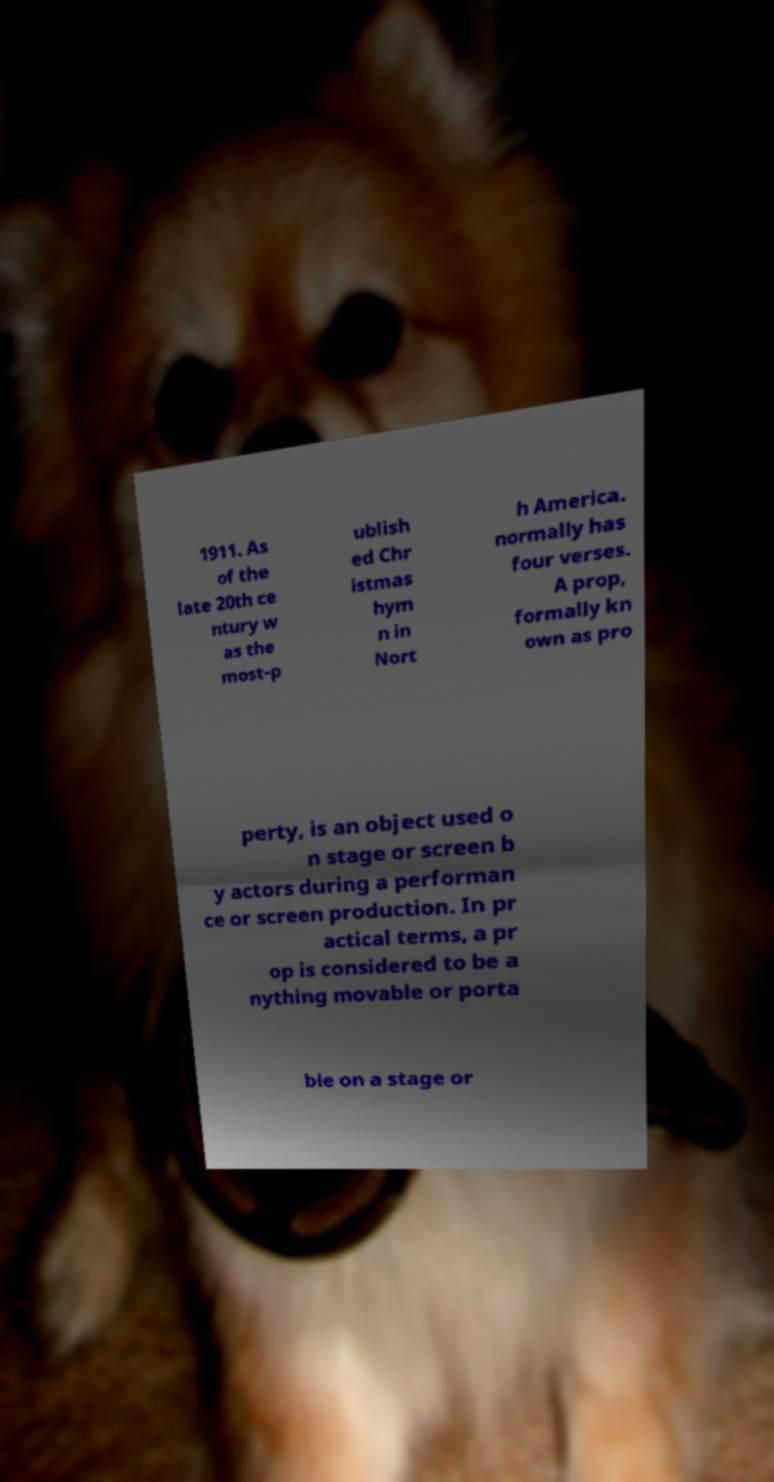For documentation purposes, I need the text within this image transcribed. Could you provide that? 1911. As of the late 20th ce ntury w as the most-p ublish ed Chr istmas hym n in Nort h America. normally has four verses. A prop, formally kn own as pro perty, is an object used o n stage or screen b y actors during a performan ce or screen production. In pr actical terms, a pr op is considered to be a nything movable or porta ble on a stage or 